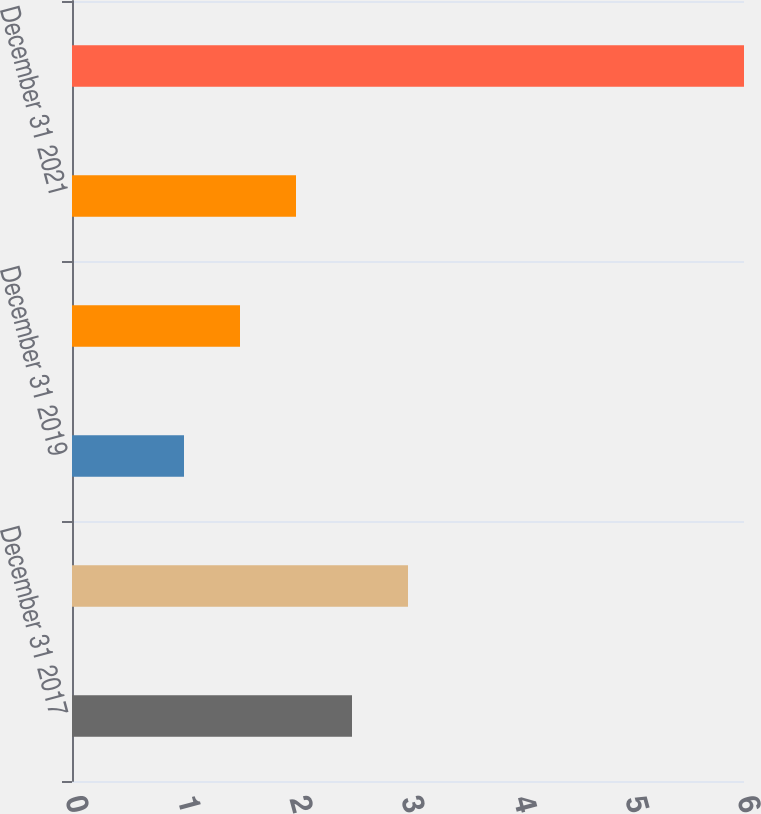Convert chart to OTSL. <chart><loc_0><loc_0><loc_500><loc_500><bar_chart><fcel>December 31 2017<fcel>December 31 2018<fcel>December 31 2019<fcel>December 31 2020<fcel>December 31 2021<fcel>December 31 2022 - 2026<nl><fcel>2.5<fcel>3<fcel>1<fcel>1.5<fcel>2<fcel>6<nl></chart> 